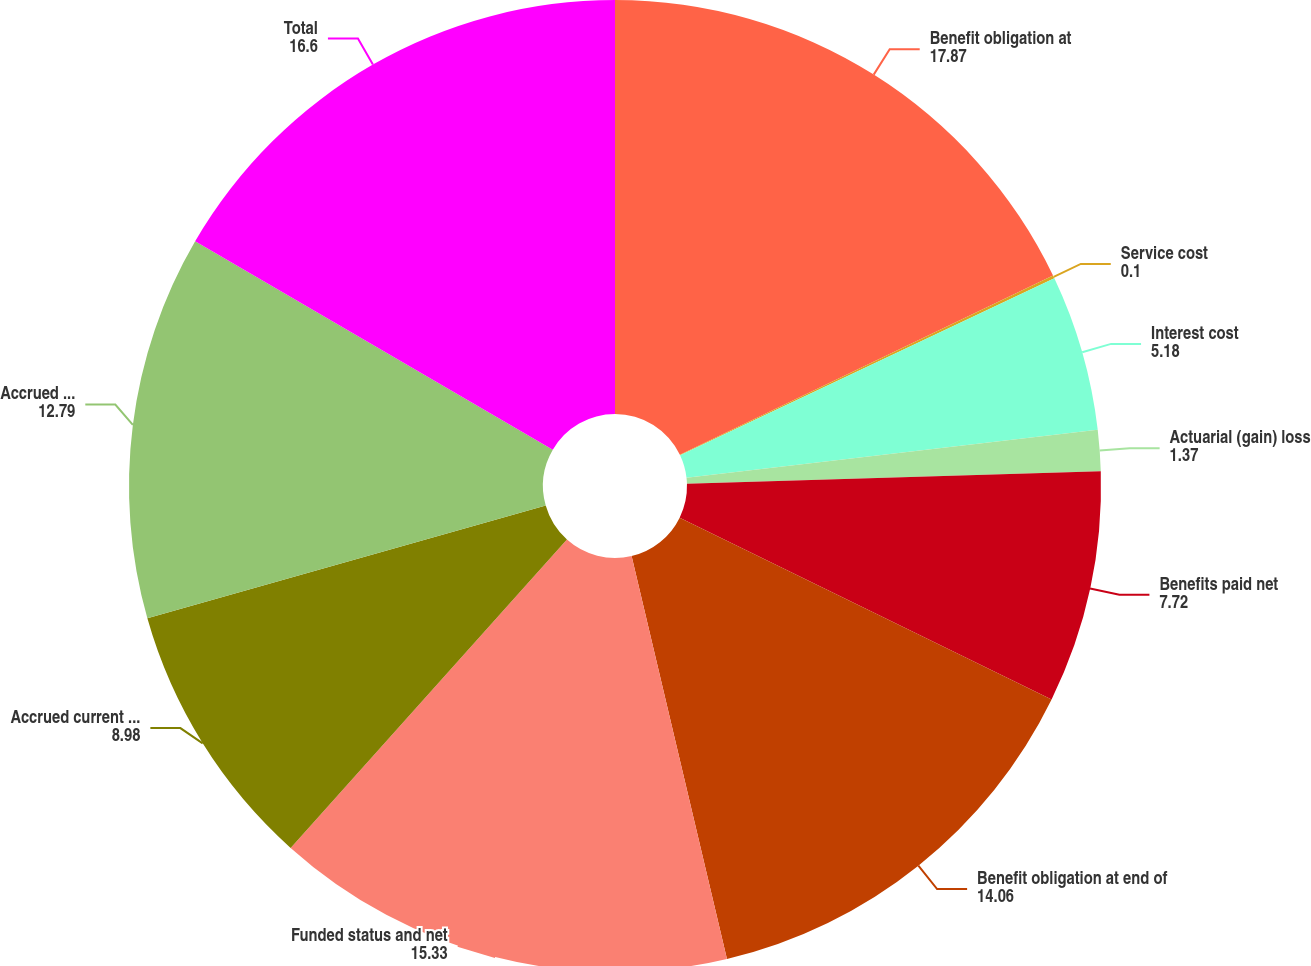Convert chart. <chart><loc_0><loc_0><loc_500><loc_500><pie_chart><fcel>Benefit obligation at<fcel>Service cost<fcel>Interest cost<fcel>Actuarial (gain) loss<fcel>Benefits paid net<fcel>Benefit obligation at end of<fcel>Funded status and net<fcel>Accrued current benefit cost<fcel>Accrued noncurrent benefit<fcel>Total<nl><fcel>17.87%<fcel>0.1%<fcel>5.18%<fcel>1.37%<fcel>7.72%<fcel>14.06%<fcel>15.33%<fcel>8.98%<fcel>12.79%<fcel>16.6%<nl></chart> 